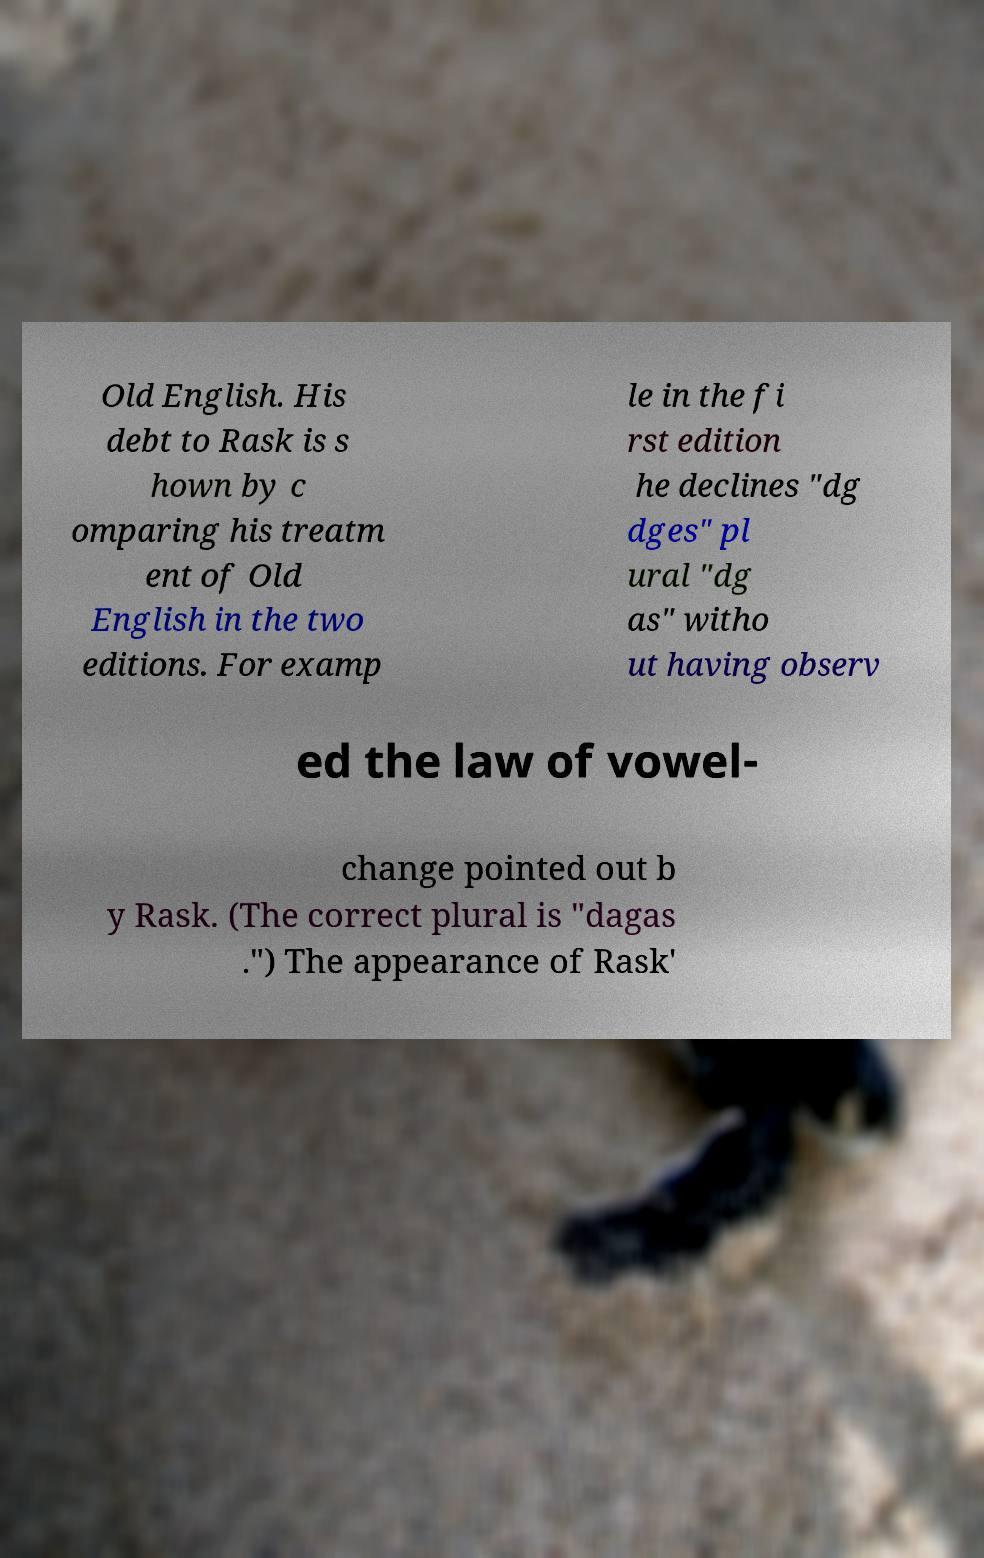What messages or text are displayed in this image? I need them in a readable, typed format. Old English. His debt to Rask is s hown by c omparing his treatm ent of Old English in the two editions. For examp le in the fi rst edition he declines "dg dges" pl ural "dg as" witho ut having observ ed the law of vowel- change pointed out b y Rask. (The correct plural is "dagas .") The appearance of Rask' 